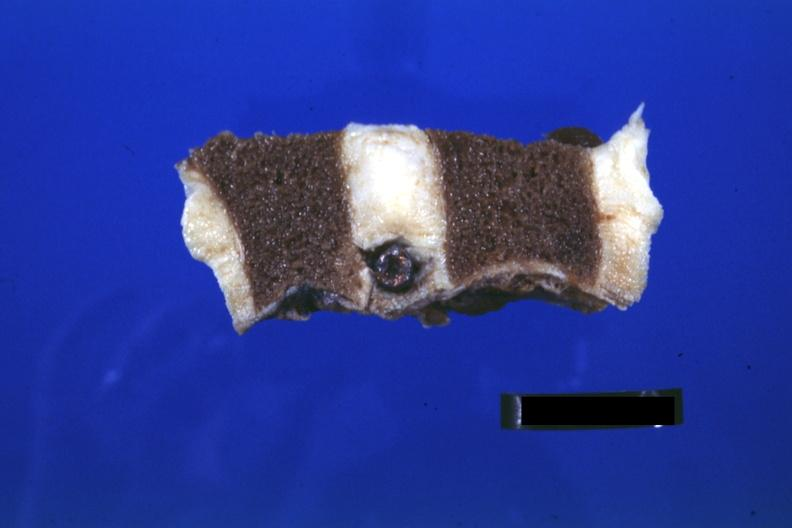what does this image show?
Answer the question using a single word or phrase. Probably natural color nice view of bullet in intervertebral disc t12-l1 